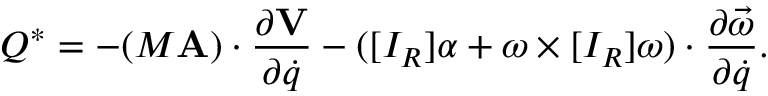<formula> <loc_0><loc_0><loc_500><loc_500>Q ^ { * } = - ( M A ) \cdot { \frac { \partial V } { \partial { \dot { q } } } } - ( [ I _ { R } ] \alpha + \omega \times [ I _ { R } ] \omega ) \cdot { \frac { \partial { \vec { \omega } } } { \partial { \dot { q } } } } .</formula> 